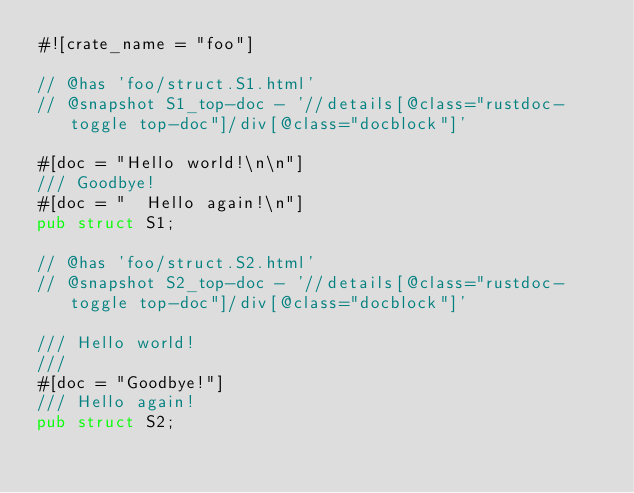<code> <loc_0><loc_0><loc_500><loc_500><_Rust_>#![crate_name = "foo"]

// @has 'foo/struct.S1.html'
// @snapshot S1_top-doc - '//details[@class="rustdoc-toggle top-doc"]/div[@class="docblock"]'

#[doc = "Hello world!\n\n"]
/// Goodbye!
#[doc = "  Hello again!\n"]
pub struct S1;

// @has 'foo/struct.S2.html'
// @snapshot S2_top-doc - '//details[@class="rustdoc-toggle top-doc"]/div[@class="docblock"]'

/// Hello world!
///
#[doc = "Goodbye!"]
/// Hello again!
pub struct S2;
</code> 